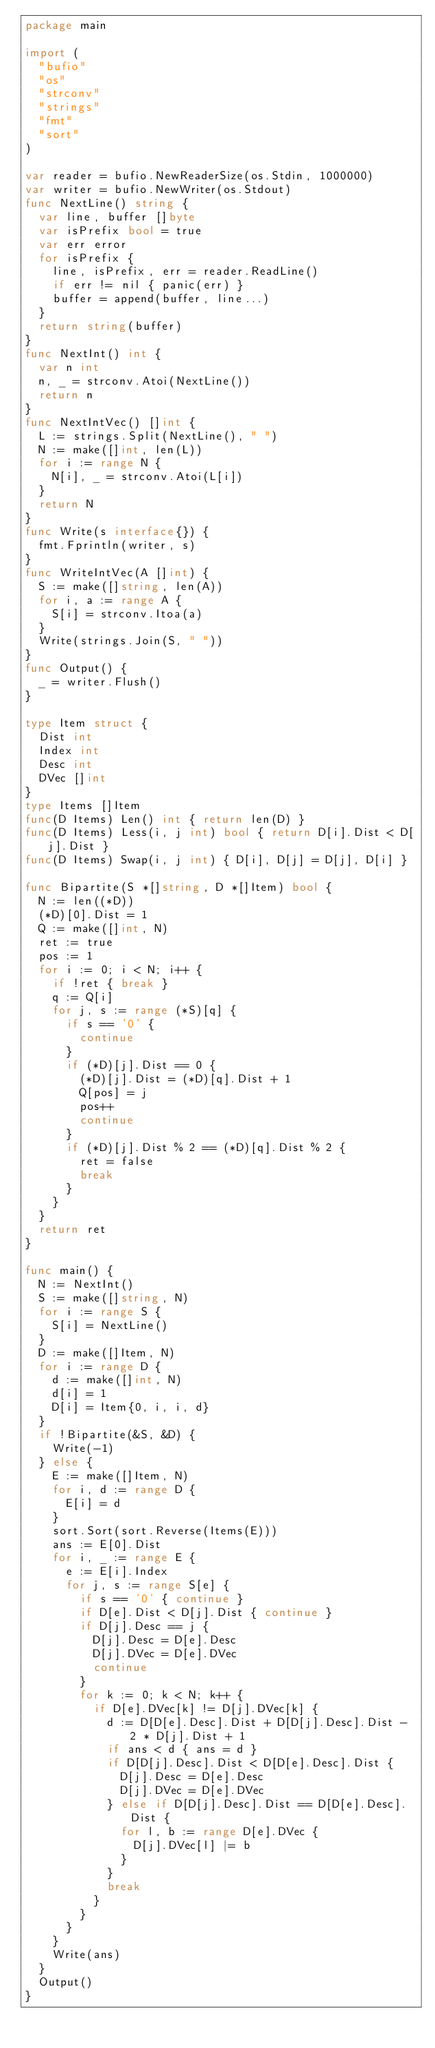<code> <loc_0><loc_0><loc_500><loc_500><_Go_>package main

import (
  "bufio"
  "os"
  "strconv"
  "strings"
  "fmt"
  "sort"
)

var reader = bufio.NewReaderSize(os.Stdin, 1000000)
var writer = bufio.NewWriter(os.Stdout)
func NextLine() string {
  var line, buffer []byte
  var isPrefix bool = true
  var err error
  for isPrefix {
    line, isPrefix, err = reader.ReadLine()
    if err != nil { panic(err) }
    buffer = append(buffer, line...)
  }
  return string(buffer)
}
func NextInt() int {
  var n int
  n, _ = strconv.Atoi(NextLine())
  return n
}
func NextIntVec() []int {
  L := strings.Split(NextLine(), " ")
  N := make([]int, len(L))
  for i := range N {
    N[i], _ = strconv.Atoi(L[i])
  }
  return N
}
func Write(s interface{}) {
  fmt.Fprintln(writer, s)
}
func WriteIntVec(A []int) {
  S := make([]string, len(A))
  for i, a := range A {
    S[i] = strconv.Itoa(a)
  }
  Write(strings.Join(S, " "))
}
func Output() {
  _ = writer.Flush()
}

type Item struct {
  Dist int
  Index int
  Desc int
  DVec []int
}
type Items []Item
func(D Items) Len() int { return len(D) }
func(D Items) Less(i, j int) bool { return D[i].Dist < D[j].Dist }
func(D Items) Swap(i, j int) { D[i], D[j] = D[j], D[i] }

func Bipartite(S *[]string, D *[]Item) bool {
  N := len((*D))
  (*D)[0].Dist = 1
  Q := make([]int, N)
  ret := true
  pos := 1
  for i := 0; i < N; i++ {
    if !ret { break }
    q := Q[i]
    for j, s := range (*S)[q] {
      if s == '0' {
        continue
      }
      if (*D)[j].Dist == 0 {
        (*D)[j].Dist = (*D)[q].Dist + 1
        Q[pos] = j
        pos++
        continue
      }
      if (*D)[j].Dist % 2 == (*D)[q].Dist % 2 {
        ret = false
        break
      }
    }
  }
  return ret
}

func main() {
  N := NextInt()
  S := make([]string, N)
  for i := range S {
    S[i] = NextLine()
  }
  D := make([]Item, N)
  for i := range D {
    d := make([]int, N)
    d[i] = 1
    D[i] = Item{0, i, i, d}
  }
  if !Bipartite(&S, &D) {
    Write(-1)
  } else {
    E := make([]Item, N)
    for i, d := range D {
      E[i] = d
    }
    sort.Sort(sort.Reverse(Items(E)))
    ans := E[0].Dist
    for i, _ := range E {
      e := E[i].Index
      for j, s := range S[e] {
        if s == '0' { continue }
        if D[e].Dist < D[j].Dist { continue }
        if D[j].Desc == j {
          D[j].Desc = D[e].Desc
          D[j].DVec = D[e].DVec
          continue
        }
        for k := 0; k < N; k++ {
          if D[e].DVec[k] != D[j].DVec[k] {
            d := D[D[e].Desc].Dist + D[D[j].Desc].Dist - 2 * D[j].Dist + 1
            if ans < d { ans = d }
            if D[D[j].Desc].Dist < D[D[e].Desc].Dist {
              D[j].Desc = D[e].Desc
              D[j].DVec = D[e].DVec
            } else if D[D[j].Desc].Dist == D[D[e].Desc].Dist {
              for l, b := range D[e].DVec {
                D[j].DVec[l] |= b
              }
            }
            break
          }
        }
      }
    }
    Write(ans)
  }
  Output()
}</code> 